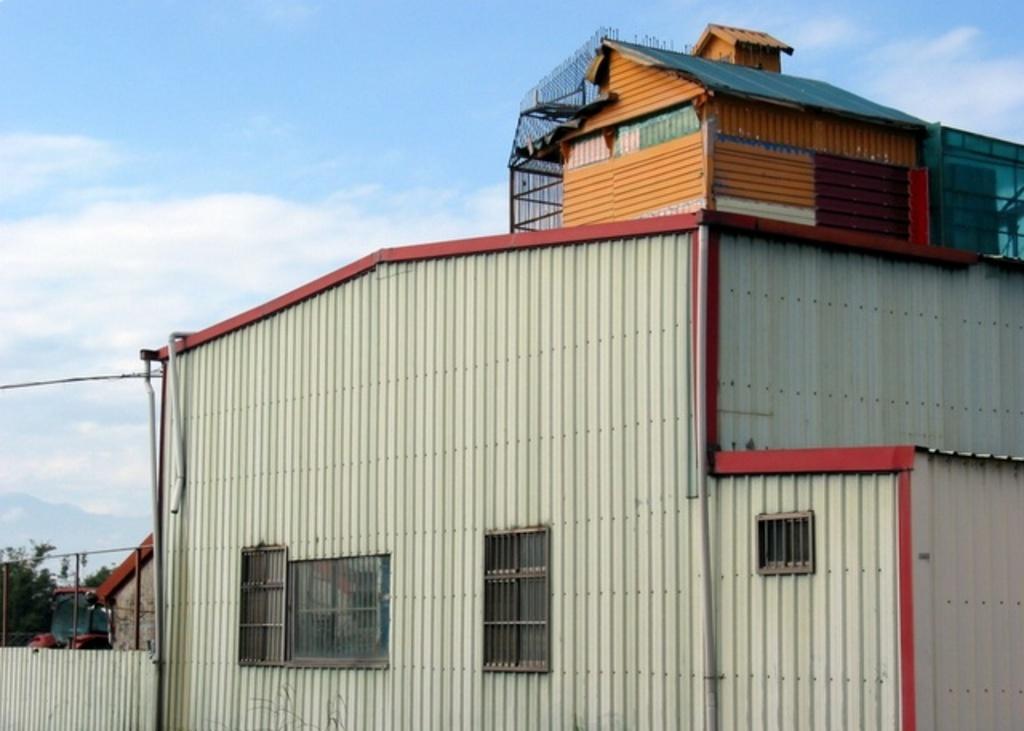In one or two sentences, can you explain what this image depicts? In the center of the image we can see a shed. In the background there is a vehicle, tree, sky and clouds. 